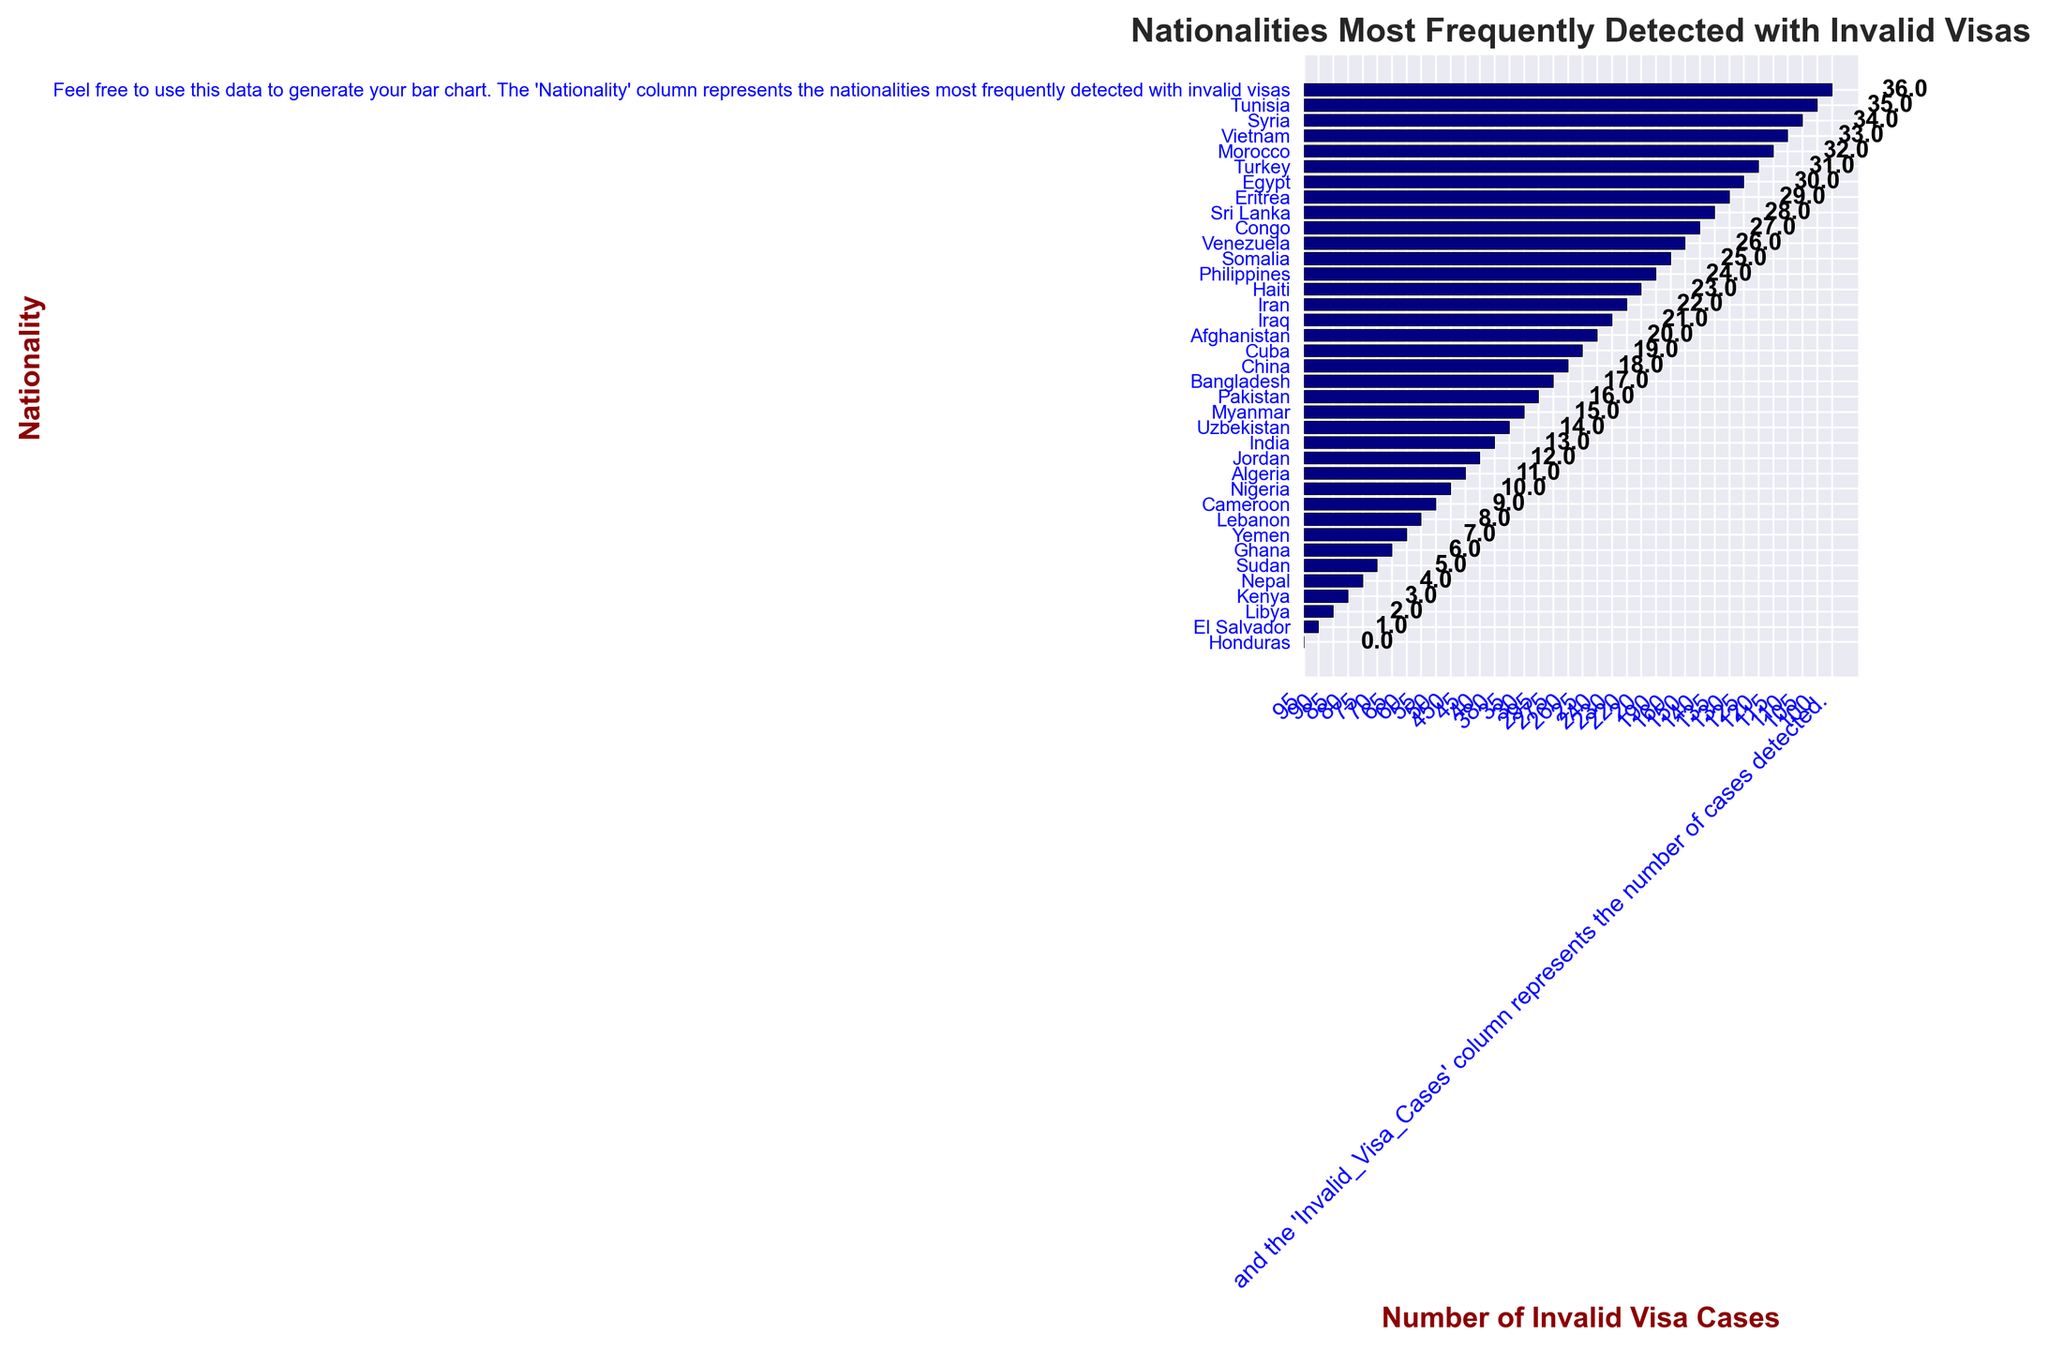What's the nationality with the highest number of invalid visa cases? By examining which bar reaches the farthest to the right, Nigeria appears to have the highest value.
Answer: Nigeria How many more invalid visa cases does India have compared to Iraq? Find the value for India (380) and subtract the value for Iraq (230) to get the difference.
Answer: 150 What is the total number of invalid visa cases for Nationalities from Africa (Nigeria, Somalia, Eritrea, Egypt, Sudan, Congo, Kenya, Ghana)? Sum each value: Nigeria (450) + Somalia (160) + Eritrea (130) + Egypt (125) + Sudan (70) + Congo (140) + Kenya (80) + Ghana (65) = 1220
Answer: 1220 Which nationalities have fewer than 100 invalid visa cases? Identify the bars whose values are less than 100: Tunisia (100), Honduras (95), El Salvador (90), Libya (85), Kenya (80), Nepal (75), Sudan (70), Ghana (65), Yemen (60), Lebanon (55), Cameroon (50), Algeria (45), Jordan (40), Uzbekistan (35), Myanmar (30), Cuba (25), Haiti (20)
Answer: Tunisia, Honduras, El Salvador, Libya, Kenya, Nepal, Sudan, Ghana, Yemen, Lebanon, Cameroon, Algeria, Jordan, Uzbekistan, Myanmar, Cuba, Haiti How many invalid visa cases are represented in the entire chart? Sum all the values: 450 + 380 + 295 + 275 + 260 + 240 + 230 + 220 + 190 + 160 + 150 + 140 + 135 + 130 + 125 + 120 + 115 + 110 + 105 + 100 + 95 + 90 + 85 + 80 + 75 + 70 + 65 + 60 + 55 + 50 + 45 + 40 + 35 + 30 + 25 + 20 = 4780
Answer: 4780 Which nationalities have invalid visa cases between 200 and 300? Identify the bars whose values fall in the 200-300 range: Pakistan (295), Bangladesh (275), China (260), Afghanistan (240), Iraq (230), Iran (220)
Answer: Pakistan, Bangladesh, China, Afghanistan, Iraq, Iran What is the average number of invalid visa cases? Sum all the values (4780) and divide by the number of nationalities (36): 4780 / 36 ≈ 132.78
Answer: 132.78 Of the nationalities listed, which have exactly equaled invalid visa cases at increments of 10 (e.g., 100, 110, 120)? Identify the bars with values that are exact multiples of 10: China (260), Afghanistan (240), Iraq (230), Iran (220), Philippines (190), Somalia (160), Congo (140), Syria (105), Tunisia (100), Kenya (80)
Answer: China, Afghanistan, Iraq, Iran, Philippines, Somalia, Congo, Syria, Tunisia, Kenya 